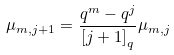<formula> <loc_0><loc_0><loc_500><loc_500>\mu _ { m , j + 1 } = \frac { q ^ { m } - q ^ { j } } { \left [ j + 1 \right ] _ { q } } \mu _ { m , j }</formula> 